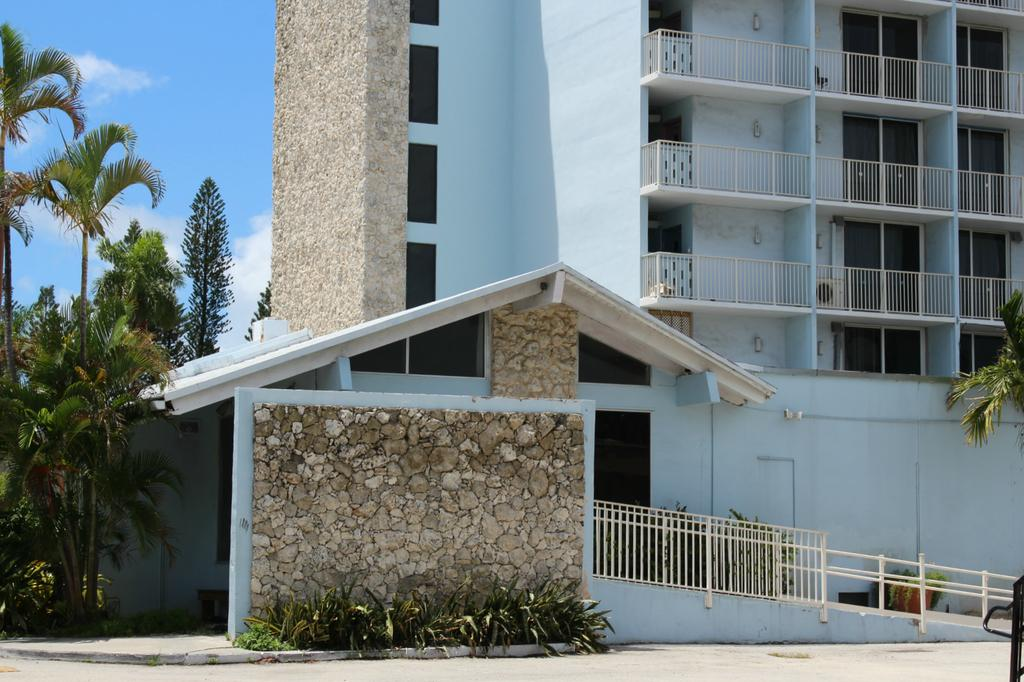What can be seen in the background of the image? The sky is visible in the background of the image. What type of structure is present in the image? There is a building in the image. What feature is present for safety or support? Railings are present in the image. Where is the image taken from? The image is taken from a rooftop, as there is a rooftop in the image. What type of vegetation is present in the image? Trees and plants are present in the image. What objects can be seen in the image? There are objects in the image, but their specific details are not mentioned in the facts. What is the purpose of the pot in the image? The purpose of the pot in the image is not mentioned in the facts. How many cactus are visible on the rooftop? There are no cactus visible on the rooftop in the image. 